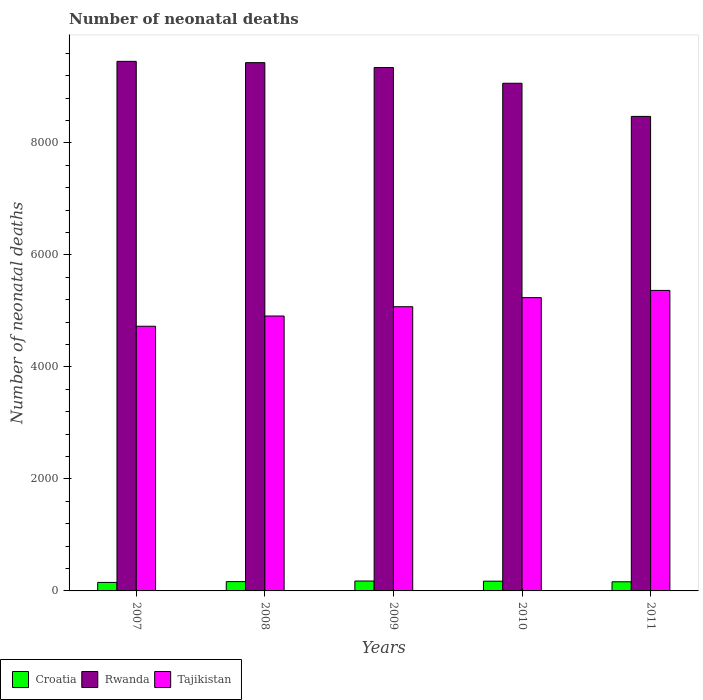How many different coloured bars are there?
Keep it short and to the point. 3. What is the label of the 4th group of bars from the left?
Provide a short and direct response. 2010. What is the number of neonatal deaths in in Croatia in 2007?
Offer a very short reply. 152. Across all years, what is the maximum number of neonatal deaths in in Croatia?
Make the answer very short. 177. Across all years, what is the minimum number of neonatal deaths in in Tajikistan?
Offer a terse response. 4726. In which year was the number of neonatal deaths in in Croatia maximum?
Your answer should be compact. 2009. What is the total number of neonatal deaths in in Tajikistan in the graph?
Your response must be concise. 2.53e+04. What is the difference between the number of neonatal deaths in in Rwanda in 2008 and that in 2009?
Your answer should be compact. 87. What is the difference between the number of neonatal deaths in in Rwanda in 2011 and the number of neonatal deaths in in Croatia in 2010?
Give a very brief answer. 8299. What is the average number of neonatal deaths in in Tajikistan per year?
Provide a short and direct response. 5062.6. In the year 2007, what is the difference between the number of neonatal deaths in in Tajikistan and number of neonatal deaths in in Croatia?
Make the answer very short. 4574. In how many years, is the number of neonatal deaths in in Tajikistan greater than 7600?
Make the answer very short. 0. What is the ratio of the number of neonatal deaths in in Rwanda in 2008 to that in 2010?
Your response must be concise. 1.04. What is the difference between the highest and the lowest number of neonatal deaths in in Rwanda?
Your answer should be compact. 983. What does the 3rd bar from the left in 2008 represents?
Make the answer very short. Tajikistan. What does the 2nd bar from the right in 2011 represents?
Offer a very short reply. Rwanda. Are all the bars in the graph horizontal?
Make the answer very short. No. Are the values on the major ticks of Y-axis written in scientific E-notation?
Give a very brief answer. No. Does the graph contain any zero values?
Offer a very short reply. No. How are the legend labels stacked?
Provide a succinct answer. Horizontal. What is the title of the graph?
Give a very brief answer. Number of neonatal deaths. Does "Gambia, The" appear as one of the legend labels in the graph?
Give a very brief answer. No. What is the label or title of the Y-axis?
Your answer should be compact. Number of neonatal deaths. What is the Number of neonatal deaths of Croatia in 2007?
Offer a very short reply. 152. What is the Number of neonatal deaths of Rwanda in 2007?
Make the answer very short. 9456. What is the Number of neonatal deaths of Tajikistan in 2007?
Provide a succinct answer. 4726. What is the Number of neonatal deaths of Croatia in 2008?
Provide a short and direct response. 166. What is the Number of neonatal deaths of Rwanda in 2008?
Your answer should be compact. 9433. What is the Number of neonatal deaths of Tajikistan in 2008?
Your answer should be compact. 4909. What is the Number of neonatal deaths in Croatia in 2009?
Your answer should be very brief. 177. What is the Number of neonatal deaths of Rwanda in 2009?
Make the answer very short. 9346. What is the Number of neonatal deaths in Tajikistan in 2009?
Offer a terse response. 5075. What is the Number of neonatal deaths in Croatia in 2010?
Provide a short and direct response. 174. What is the Number of neonatal deaths in Rwanda in 2010?
Make the answer very short. 9065. What is the Number of neonatal deaths of Tajikistan in 2010?
Provide a succinct answer. 5237. What is the Number of neonatal deaths of Croatia in 2011?
Offer a very short reply. 163. What is the Number of neonatal deaths of Rwanda in 2011?
Your answer should be very brief. 8473. What is the Number of neonatal deaths of Tajikistan in 2011?
Ensure brevity in your answer.  5366. Across all years, what is the maximum Number of neonatal deaths of Croatia?
Keep it short and to the point. 177. Across all years, what is the maximum Number of neonatal deaths in Rwanda?
Give a very brief answer. 9456. Across all years, what is the maximum Number of neonatal deaths of Tajikistan?
Keep it short and to the point. 5366. Across all years, what is the minimum Number of neonatal deaths of Croatia?
Offer a terse response. 152. Across all years, what is the minimum Number of neonatal deaths in Rwanda?
Your response must be concise. 8473. Across all years, what is the minimum Number of neonatal deaths in Tajikistan?
Give a very brief answer. 4726. What is the total Number of neonatal deaths in Croatia in the graph?
Make the answer very short. 832. What is the total Number of neonatal deaths in Rwanda in the graph?
Your answer should be very brief. 4.58e+04. What is the total Number of neonatal deaths in Tajikistan in the graph?
Give a very brief answer. 2.53e+04. What is the difference between the Number of neonatal deaths of Croatia in 2007 and that in 2008?
Offer a terse response. -14. What is the difference between the Number of neonatal deaths in Rwanda in 2007 and that in 2008?
Ensure brevity in your answer.  23. What is the difference between the Number of neonatal deaths of Tajikistan in 2007 and that in 2008?
Make the answer very short. -183. What is the difference between the Number of neonatal deaths in Rwanda in 2007 and that in 2009?
Offer a terse response. 110. What is the difference between the Number of neonatal deaths in Tajikistan in 2007 and that in 2009?
Keep it short and to the point. -349. What is the difference between the Number of neonatal deaths in Croatia in 2007 and that in 2010?
Your answer should be very brief. -22. What is the difference between the Number of neonatal deaths of Rwanda in 2007 and that in 2010?
Offer a very short reply. 391. What is the difference between the Number of neonatal deaths of Tajikistan in 2007 and that in 2010?
Ensure brevity in your answer.  -511. What is the difference between the Number of neonatal deaths in Croatia in 2007 and that in 2011?
Your answer should be compact. -11. What is the difference between the Number of neonatal deaths of Rwanda in 2007 and that in 2011?
Your answer should be compact. 983. What is the difference between the Number of neonatal deaths in Tajikistan in 2007 and that in 2011?
Provide a short and direct response. -640. What is the difference between the Number of neonatal deaths of Rwanda in 2008 and that in 2009?
Ensure brevity in your answer.  87. What is the difference between the Number of neonatal deaths in Tajikistan in 2008 and that in 2009?
Provide a succinct answer. -166. What is the difference between the Number of neonatal deaths of Croatia in 2008 and that in 2010?
Keep it short and to the point. -8. What is the difference between the Number of neonatal deaths in Rwanda in 2008 and that in 2010?
Give a very brief answer. 368. What is the difference between the Number of neonatal deaths in Tajikistan in 2008 and that in 2010?
Your answer should be very brief. -328. What is the difference between the Number of neonatal deaths of Croatia in 2008 and that in 2011?
Give a very brief answer. 3. What is the difference between the Number of neonatal deaths in Rwanda in 2008 and that in 2011?
Give a very brief answer. 960. What is the difference between the Number of neonatal deaths in Tajikistan in 2008 and that in 2011?
Your answer should be very brief. -457. What is the difference between the Number of neonatal deaths in Croatia in 2009 and that in 2010?
Keep it short and to the point. 3. What is the difference between the Number of neonatal deaths in Rwanda in 2009 and that in 2010?
Offer a terse response. 281. What is the difference between the Number of neonatal deaths of Tajikistan in 2009 and that in 2010?
Your response must be concise. -162. What is the difference between the Number of neonatal deaths in Rwanda in 2009 and that in 2011?
Your response must be concise. 873. What is the difference between the Number of neonatal deaths of Tajikistan in 2009 and that in 2011?
Keep it short and to the point. -291. What is the difference between the Number of neonatal deaths in Croatia in 2010 and that in 2011?
Give a very brief answer. 11. What is the difference between the Number of neonatal deaths in Rwanda in 2010 and that in 2011?
Your answer should be very brief. 592. What is the difference between the Number of neonatal deaths in Tajikistan in 2010 and that in 2011?
Your answer should be very brief. -129. What is the difference between the Number of neonatal deaths in Croatia in 2007 and the Number of neonatal deaths in Rwanda in 2008?
Keep it short and to the point. -9281. What is the difference between the Number of neonatal deaths in Croatia in 2007 and the Number of neonatal deaths in Tajikistan in 2008?
Keep it short and to the point. -4757. What is the difference between the Number of neonatal deaths of Rwanda in 2007 and the Number of neonatal deaths of Tajikistan in 2008?
Offer a very short reply. 4547. What is the difference between the Number of neonatal deaths of Croatia in 2007 and the Number of neonatal deaths of Rwanda in 2009?
Your response must be concise. -9194. What is the difference between the Number of neonatal deaths in Croatia in 2007 and the Number of neonatal deaths in Tajikistan in 2009?
Keep it short and to the point. -4923. What is the difference between the Number of neonatal deaths of Rwanda in 2007 and the Number of neonatal deaths of Tajikistan in 2009?
Make the answer very short. 4381. What is the difference between the Number of neonatal deaths of Croatia in 2007 and the Number of neonatal deaths of Rwanda in 2010?
Offer a terse response. -8913. What is the difference between the Number of neonatal deaths of Croatia in 2007 and the Number of neonatal deaths of Tajikistan in 2010?
Offer a terse response. -5085. What is the difference between the Number of neonatal deaths in Rwanda in 2007 and the Number of neonatal deaths in Tajikistan in 2010?
Give a very brief answer. 4219. What is the difference between the Number of neonatal deaths in Croatia in 2007 and the Number of neonatal deaths in Rwanda in 2011?
Provide a short and direct response. -8321. What is the difference between the Number of neonatal deaths in Croatia in 2007 and the Number of neonatal deaths in Tajikistan in 2011?
Offer a very short reply. -5214. What is the difference between the Number of neonatal deaths of Rwanda in 2007 and the Number of neonatal deaths of Tajikistan in 2011?
Make the answer very short. 4090. What is the difference between the Number of neonatal deaths of Croatia in 2008 and the Number of neonatal deaths of Rwanda in 2009?
Your response must be concise. -9180. What is the difference between the Number of neonatal deaths in Croatia in 2008 and the Number of neonatal deaths in Tajikistan in 2009?
Keep it short and to the point. -4909. What is the difference between the Number of neonatal deaths in Rwanda in 2008 and the Number of neonatal deaths in Tajikistan in 2009?
Provide a short and direct response. 4358. What is the difference between the Number of neonatal deaths in Croatia in 2008 and the Number of neonatal deaths in Rwanda in 2010?
Your response must be concise. -8899. What is the difference between the Number of neonatal deaths of Croatia in 2008 and the Number of neonatal deaths of Tajikistan in 2010?
Ensure brevity in your answer.  -5071. What is the difference between the Number of neonatal deaths in Rwanda in 2008 and the Number of neonatal deaths in Tajikistan in 2010?
Offer a very short reply. 4196. What is the difference between the Number of neonatal deaths in Croatia in 2008 and the Number of neonatal deaths in Rwanda in 2011?
Ensure brevity in your answer.  -8307. What is the difference between the Number of neonatal deaths in Croatia in 2008 and the Number of neonatal deaths in Tajikistan in 2011?
Your answer should be very brief. -5200. What is the difference between the Number of neonatal deaths of Rwanda in 2008 and the Number of neonatal deaths of Tajikistan in 2011?
Offer a terse response. 4067. What is the difference between the Number of neonatal deaths of Croatia in 2009 and the Number of neonatal deaths of Rwanda in 2010?
Your answer should be compact. -8888. What is the difference between the Number of neonatal deaths in Croatia in 2009 and the Number of neonatal deaths in Tajikistan in 2010?
Ensure brevity in your answer.  -5060. What is the difference between the Number of neonatal deaths of Rwanda in 2009 and the Number of neonatal deaths of Tajikistan in 2010?
Your response must be concise. 4109. What is the difference between the Number of neonatal deaths in Croatia in 2009 and the Number of neonatal deaths in Rwanda in 2011?
Provide a succinct answer. -8296. What is the difference between the Number of neonatal deaths of Croatia in 2009 and the Number of neonatal deaths of Tajikistan in 2011?
Provide a short and direct response. -5189. What is the difference between the Number of neonatal deaths of Rwanda in 2009 and the Number of neonatal deaths of Tajikistan in 2011?
Provide a short and direct response. 3980. What is the difference between the Number of neonatal deaths of Croatia in 2010 and the Number of neonatal deaths of Rwanda in 2011?
Your answer should be very brief. -8299. What is the difference between the Number of neonatal deaths in Croatia in 2010 and the Number of neonatal deaths in Tajikistan in 2011?
Your answer should be compact. -5192. What is the difference between the Number of neonatal deaths in Rwanda in 2010 and the Number of neonatal deaths in Tajikistan in 2011?
Your answer should be very brief. 3699. What is the average Number of neonatal deaths of Croatia per year?
Make the answer very short. 166.4. What is the average Number of neonatal deaths of Rwanda per year?
Offer a very short reply. 9154.6. What is the average Number of neonatal deaths in Tajikistan per year?
Give a very brief answer. 5062.6. In the year 2007, what is the difference between the Number of neonatal deaths of Croatia and Number of neonatal deaths of Rwanda?
Make the answer very short. -9304. In the year 2007, what is the difference between the Number of neonatal deaths of Croatia and Number of neonatal deaths of Tajikistan?
Give a very brief answer. -4574. In the year 2007, what is the difference between the Number of neonatal deaths of Rwanda and Number of neonatal deaths of Tajikistan?
Give a very brief answer. 4730. In the year 2008, what is the difference between the Number of neonatal deaths in Croatia and Number of neonatal deaths in Rwanda?
Offer a very short reply. -9267. In the year 2008, what is the difference between the Number of neonatal deaths in Croatia and Number of neonatal deaths in Tajikistan?
Your answer should be compact. -4743. In the year 2008, what is the difference between the Number of neonatal deaths of Rwanda and Number of neonatal deaths of Tajikistan?
Offer a terse response. 4524. In the year 2009, what is the difference between the Number of neonatal deaths in Croatia and Number of neonatal deaths in Rwanda?
Offer a terse response. -9169. In the year 2009, what is the difference between the Number of neonatal deaths of Croatia and Number of neonatal deaths of Tajikistan?
Give a very brief answer. -4898. In the year 2009, what is the difference between the Number of neonatal deaths in Rwanda and Number of neonatal deaths in Tajikistan?
Provide a succinct answer. 4271. In the year 2010, what is the difference between the Number of neonatal deaths of Croatia and Number of neonatal deaths of Rwanda?
Give a very brief answer. -8891. In the year 2010, what is the difference between the Number of neonatal deaths in Croatia and Number of neonatal deaths in Tajikistan?
Provide a succinct answer. -5063. In the year 2010, what is the difference between the Number of neonatal deaths of Rwanda and Number of neonatal deaths of Tajikistan?
Offer a very short reply. 3828. In the year 2011, what is the difference between the Number of neonatal deaths in Croatia and Number of neonatal deaths in Rwanda?
Ensure brevity in your answer.  -8310. In the year 2011, what is the difference between the Number of neonatal deaths of Croatia and Number of neonatal deaths of Tajikistan?
Your response must be concise. -5203. In the year 2011, what is the difference between the Number of neonatal deaths in Rwanda and Number of neonatal deaths in Tajikistan?
Provide a short and direct response. 3107. What is the ratio of the Number of neonatal deaths in Croatia in 2007 to that in 2008?
Ensure brevity in your answer.  0.92. What is the ratio of the Number of neonatal deaths in Tajikistan in 2007 to that in 2008?
Keep it short and to the point. 0.96. What is the ratio of the Number of neonatal deaths in Croatia in 2007 to that in 2009?
Provide a short and direct response. 0.86. What is the ratio of the Number of neonatal deaths of Rwanda in 2007 to that in 2009?
Keep it short and to the point. 1.01. What is the ratio of the Number of neonatal deaths in Tajikistan in 2007 to that in 2009?
Your response must be concise. 0.93. What is the ratio of the Number of neonatal deaths of Croatia in 2007 to that in 2010?
Your answer should be compact. 0.87. What is the ratio of the Number of neonatal deaths of Rwanda in 2007 to that in 2010?
Ensure brevity in your answer.  1.04. What is the ratio of the Number of neonatal deaths of Tajikistan in 2007 to that in 2010?
Offer a terse response. 0.9. What is the ratio of the Number of neonatal deaths of Croatia in 2007 to that in 2011?
Give a very brief answer. 0.93. What is the ratio of the Number of neonatal deaths in Rwanda in 2007 to that in 2011?
Offer a very short reply. 1.12. What is the ratio of the Number of neonatal deaths in Tajikistan in 2007 to that in 2011?
Give a very brief answer. 0.88. What is the ratio of the Number of neonatal deaths in Croatia in 2008 to that in 2009?
Offer a very short reply. 0.94. What is the ratio of the Number of neonatal deaths of Rwanda in 2008 to that in 2009?
Provide a succinct answer. 1.01. What is the ratio of the Number of neonatal deaths of Tajikistan in 2008 to that in 2009?
Provide a short and direct response. 0.97. What is the ratio of the Number of neonatal deaths of Croatia in 2008 to that in 2010?
Make the answer very short. 0.95. What is the ratio of the Number of neonatal deaths of Rwanda in 2008 to that in 2010?
Provide a short and direct response. 1.04. What is the ratio of the Number of neonatal deaths in Tajikistan in 2008 to that in 2010?
Ensure brevity in your answer.  0.94. What is the ratio of the Number of neonatal deaths in Croatia in 2008 to that in 2011?
Make the answer very short. 1.02. What is the ratio of the Number of neonatal deaths in Rwanda in 2008 to that in 2011?
Make the answer very short. 1.11. What is the ratio of the Number of neonatal deaths of Tajikistan in 2008 to that in 2011?
Make the answer very short. 0.91. What is the ratio of the Number of neonatal deaths of Croatia in 2009 to that in 2010?
Provide a short and direct response. 1.02. What is the ratio of the Number of neonatal deaths in Rwanda in 2009 to that in 2010?
Ensure brevity in your answer.  1.03. What is the ratio of the Number of neonatal deaths of Tajikistan in 2009 to that in 2010?
Your response must be concise. 0.97. What is the ratio of the Number of neonatal deaths in Croatia in 2009 to that in 2011?
Offer a very short reply. 1.09. What is the ratio of the Number of neonatal deaths in Rwanda in 2009 to that in 2011?
Your answer should be very brief. 1.1. What is the ratio of the Number of neonatal deaths of Tajikistan in 2009 to that in 2011?
Provide a succinct answer. 0.95. What is the ratio of the Number of neonatal deaths of Croatia in 2010 to that in 2011?
Your answer should be compact. 1.07. What is the ratio of the Number of neonatal deaths in Rwanda in 2010 to that in 2011?
Keep it short and to the point. 1.07. What is the difference between the highest and the second highest Number of neonatal deaths in Croatia?
Ensure brevity in your answer.  3. What is the difference between the highest and the second highest Number of neonatal deaths in Rwanda?
Keep it short and to the point. 23. What is the difference between the highest and the second highest Number of neonatal deaths of Tajikistan?
Ensure brevity in your answer.  129. What is the difference between the highest and the lowest Number of neonatal deaths in Croatia?
Provide a succinct answer. 25. What is the difference between the highest and the lowest Number of neonatal deaths in Rwanda?
Your response must be concise. 983. What is the difference between the highest and the lowest Number of neonatal deaths in Tajikistan?
Provide a succinct answer. 640. 